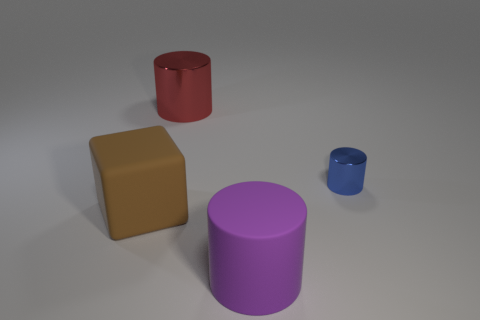How big is the shiny thing on the right side of the big cylinder that is behind the big matte object that is right of the big red object?
Offer a terse response. Small. Are there any big red metal things right of the blue shiny object?
Provide a succinct answer. No. There is a purple rubber thing; is its size the same as the cylinder behind the small blue object?
Ensure brevity in your answer.  Yes. What shape is the big object that is behind the large matte cylinder and in front of the large red metallic cylinder?
Provide a succinct answer. Cube. There is a rubber thing behind the large purple rubber cylinder; is it the same size as the rubber thing that is right of the brown object?
Offer a terse response. Yes. There is a big purple object that is the same material as the large brown cube; what is its shape?
Provide a short and direct response. Cylinder. Is there anything else that has the same shape as the red metal object?
Provide a succinct answer. Yes. What color is the metal object behind the metallic thing on the right side of the large cylinder behind the matte cylinder?
Your response must be concise. Red. Is the number of blue shiny cylinders that are left of the brown block less than the number of large red cylinders to the right of the blue metal cylinder?
Give a very brief answer. No. Do the small blue object and the brown matte object have the same shape?
Offer a terse response. No. 